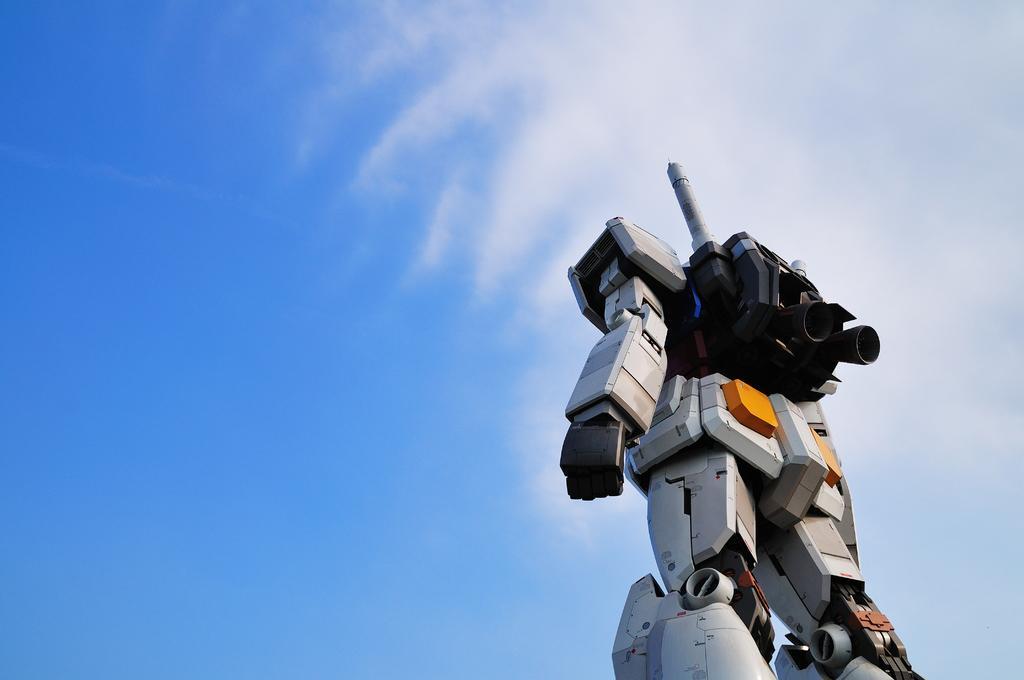In one or two sentences, can you explain what this image depicts? In this image there is a robot towards the bottom of the image, there is the sky, there are clouds in the sky. 